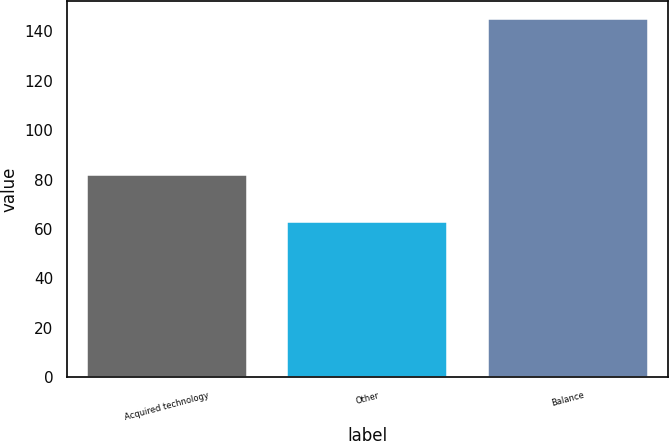Convert chart to OTSL. <chart><loc_0><loc_0><loc_500><loc_500><bar_chart><fcel>Acquired technology<fcel>Other<fcel>Balance<nl><fcel>82<fcel>63<fcel>145<nl></chart> 